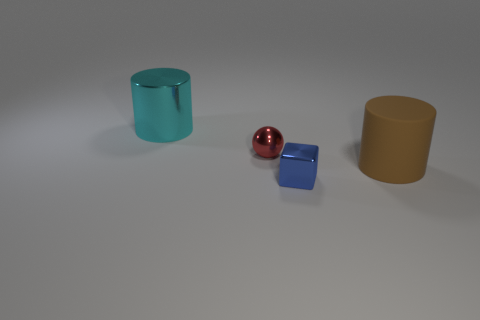Do the tiny metallic sphere and the big thing to the right of the blue metallic object have the same color?
Provide a short and direct response. No. What material is the thing that is the same size as the cyan cylinder?
Make the answer very short. Rubber. Is the number of small blue blocks that are behind the cyan thing less than the number of small red metallic spheres that are to the right of the brown object?
Provide a short and direct response. No. There is a large thing to the left of the small metallic object in front of the big brown cylinder; what is its shape?
Provide a succinct answer. Cylinder. Are any cylinders visible?
Your answer should be compact. Yes. There is a object that is in front of the large brown rubber object; what is its color?
Give a very brief answer. Blue. There is a sphere; are there any brown rubber cylinders in front of it?
Offer a terse response. Yes. Are there more small things than tiny blue cubes?
Ensure brevity in your answer.  Yes. What is the color of the big object behind the thing right of the metallic thing that is in front of the rubber object?
Your answer should be compact. Cyan. What is the color of the tiny thing that is made of the same material as the block?
Provide a short and direct response. Red. 